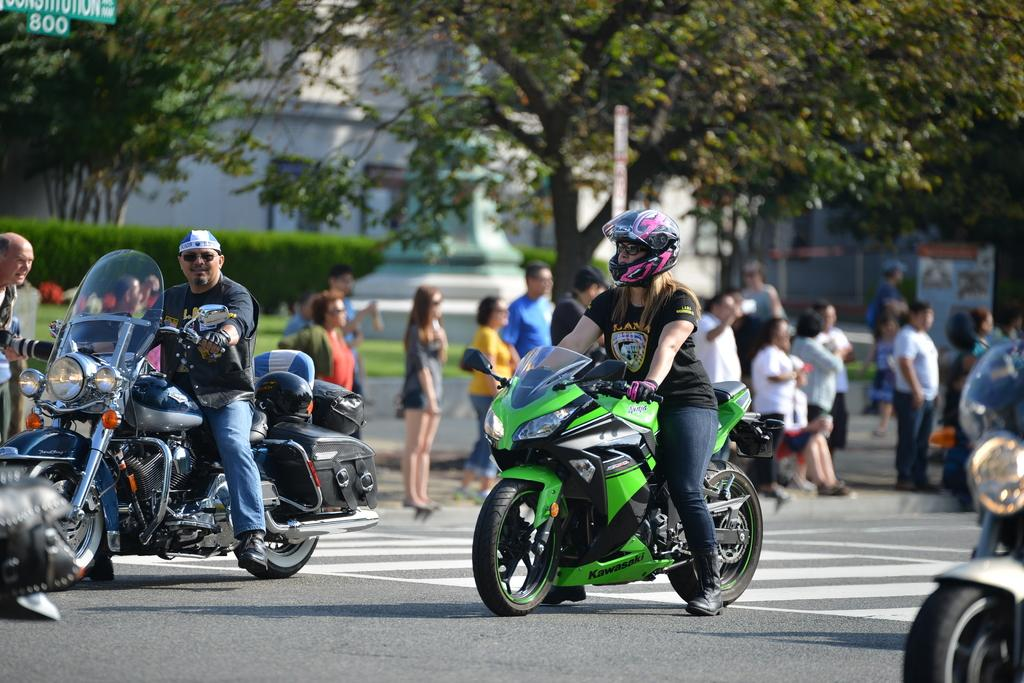What are the people doing in the image? The people are sitting on a bike in the image. Where is the bike located? The bike is on the road. Are there any other people involved in the scene? Yes, there are people standing at the back of the bike. What can be seen in the surrounding environment? There are trees in the area. What time is displayed on the clock in the image? There is no clock present in the image. What type of amusement can be seen in the image? There is no amusement activity depicted in the image; it features people sitting on a bike on the road. 